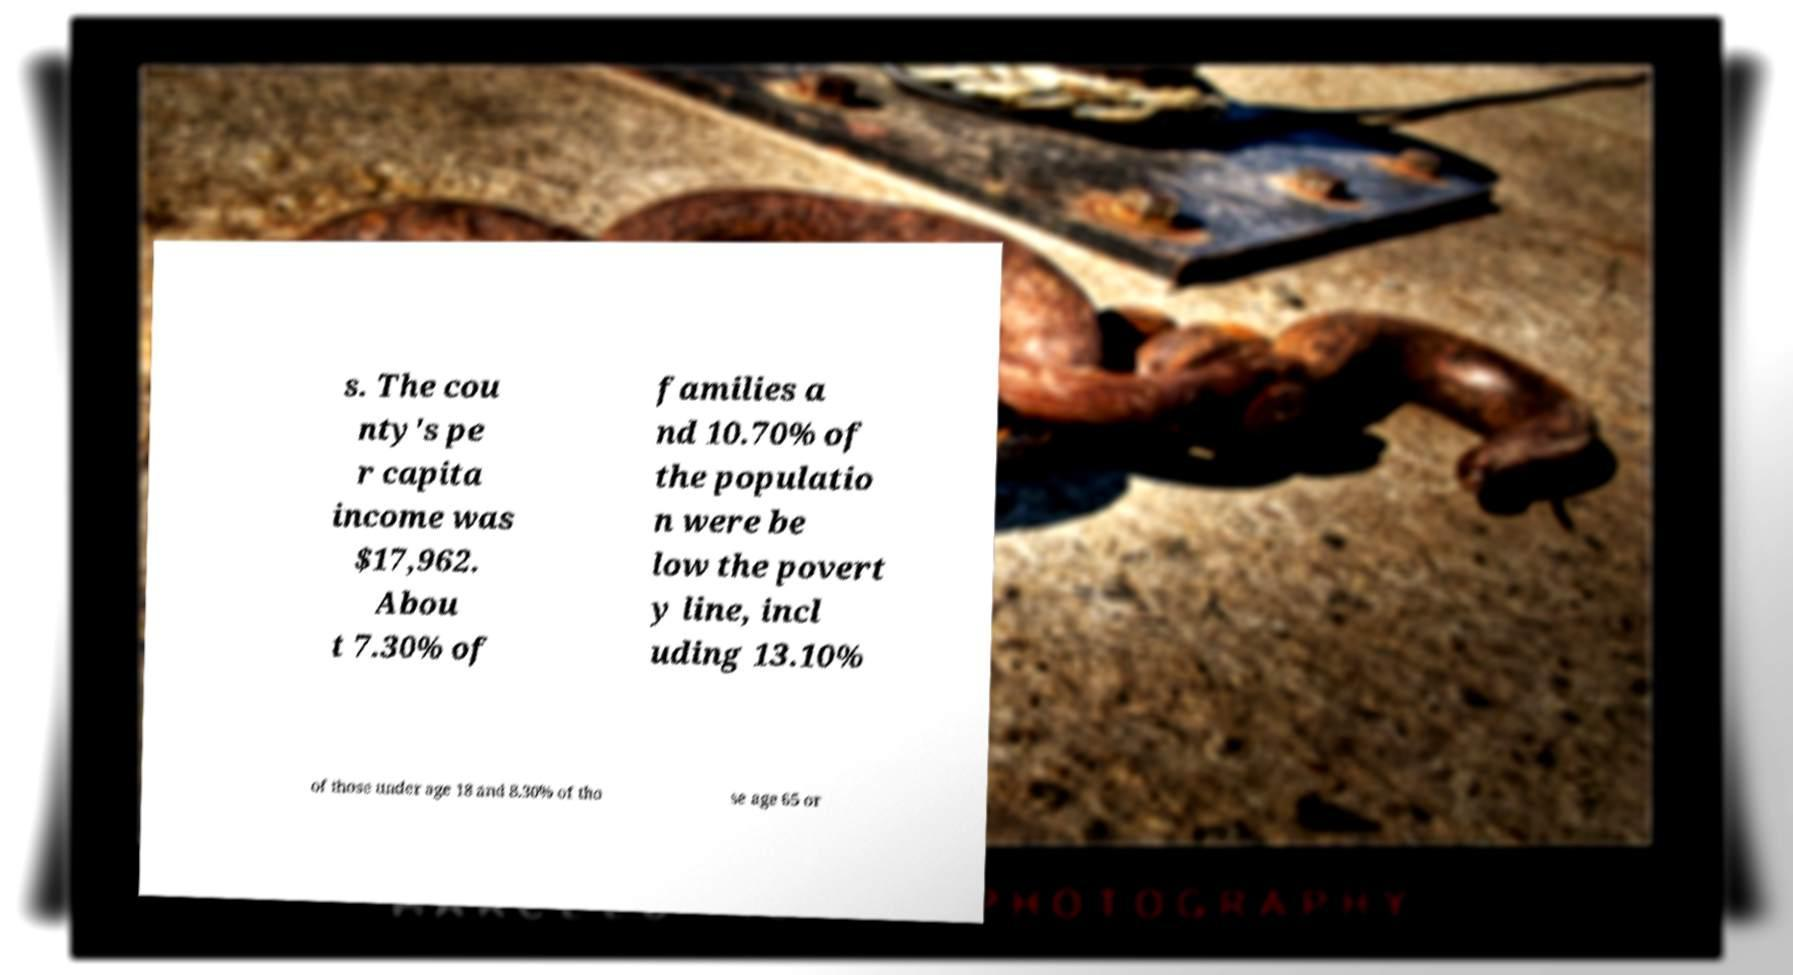Please identify and transcribe the text found in this image. s. The cou nty's pe r capita income was $17,962. Abou t 7.30% of families a nd 10.70% of the populatio n were be low the povert y line, incl uding 13.10% of those under age 18 and 8.30% of tho se age 65 or 